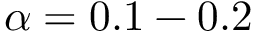Convert formula to latex. <formula><loc_0><loc_0><loc_500><loc_500>\alpha = 0 . 1 - 0 . 2</formula> 